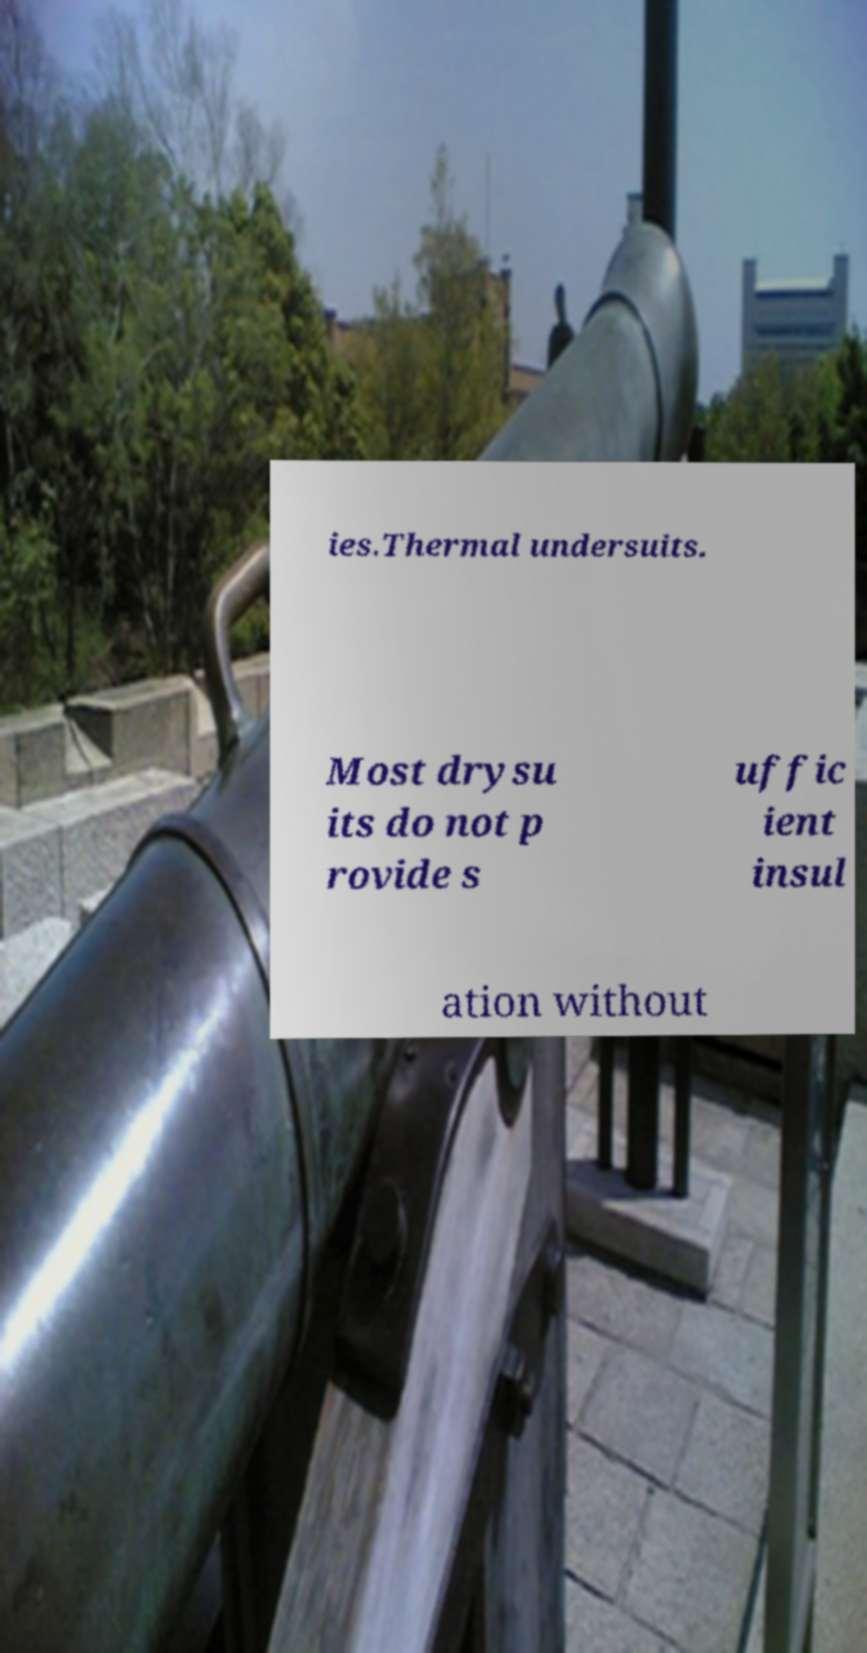Can you accurately transcribe the text from the provided image for me? ies.Thermal undersuits. Most drysu its do not p rovide s uffic ient insul ation without 